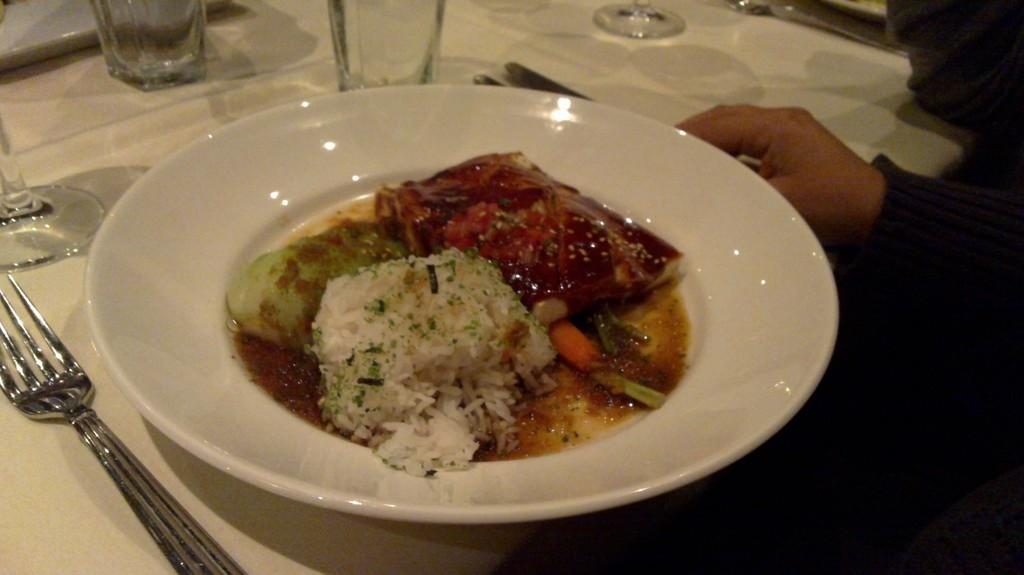What is on the plate that is visible in the image? There is a plate containing food in the image. What utensils are present on the table in the image? There are forks and spoons on the table in the image. What can be used for drinking in the image? There are glasses on the table that can be used for drinking. What piece of furniture is present in the image? The table is present in the image. Can you see a person's hand in the image? Yes, there is a hand of a person on the right side of the image. What is the tendency of the tramp in the image? There is no tramp present in the image, so it is not possible to determine any tendencies. 